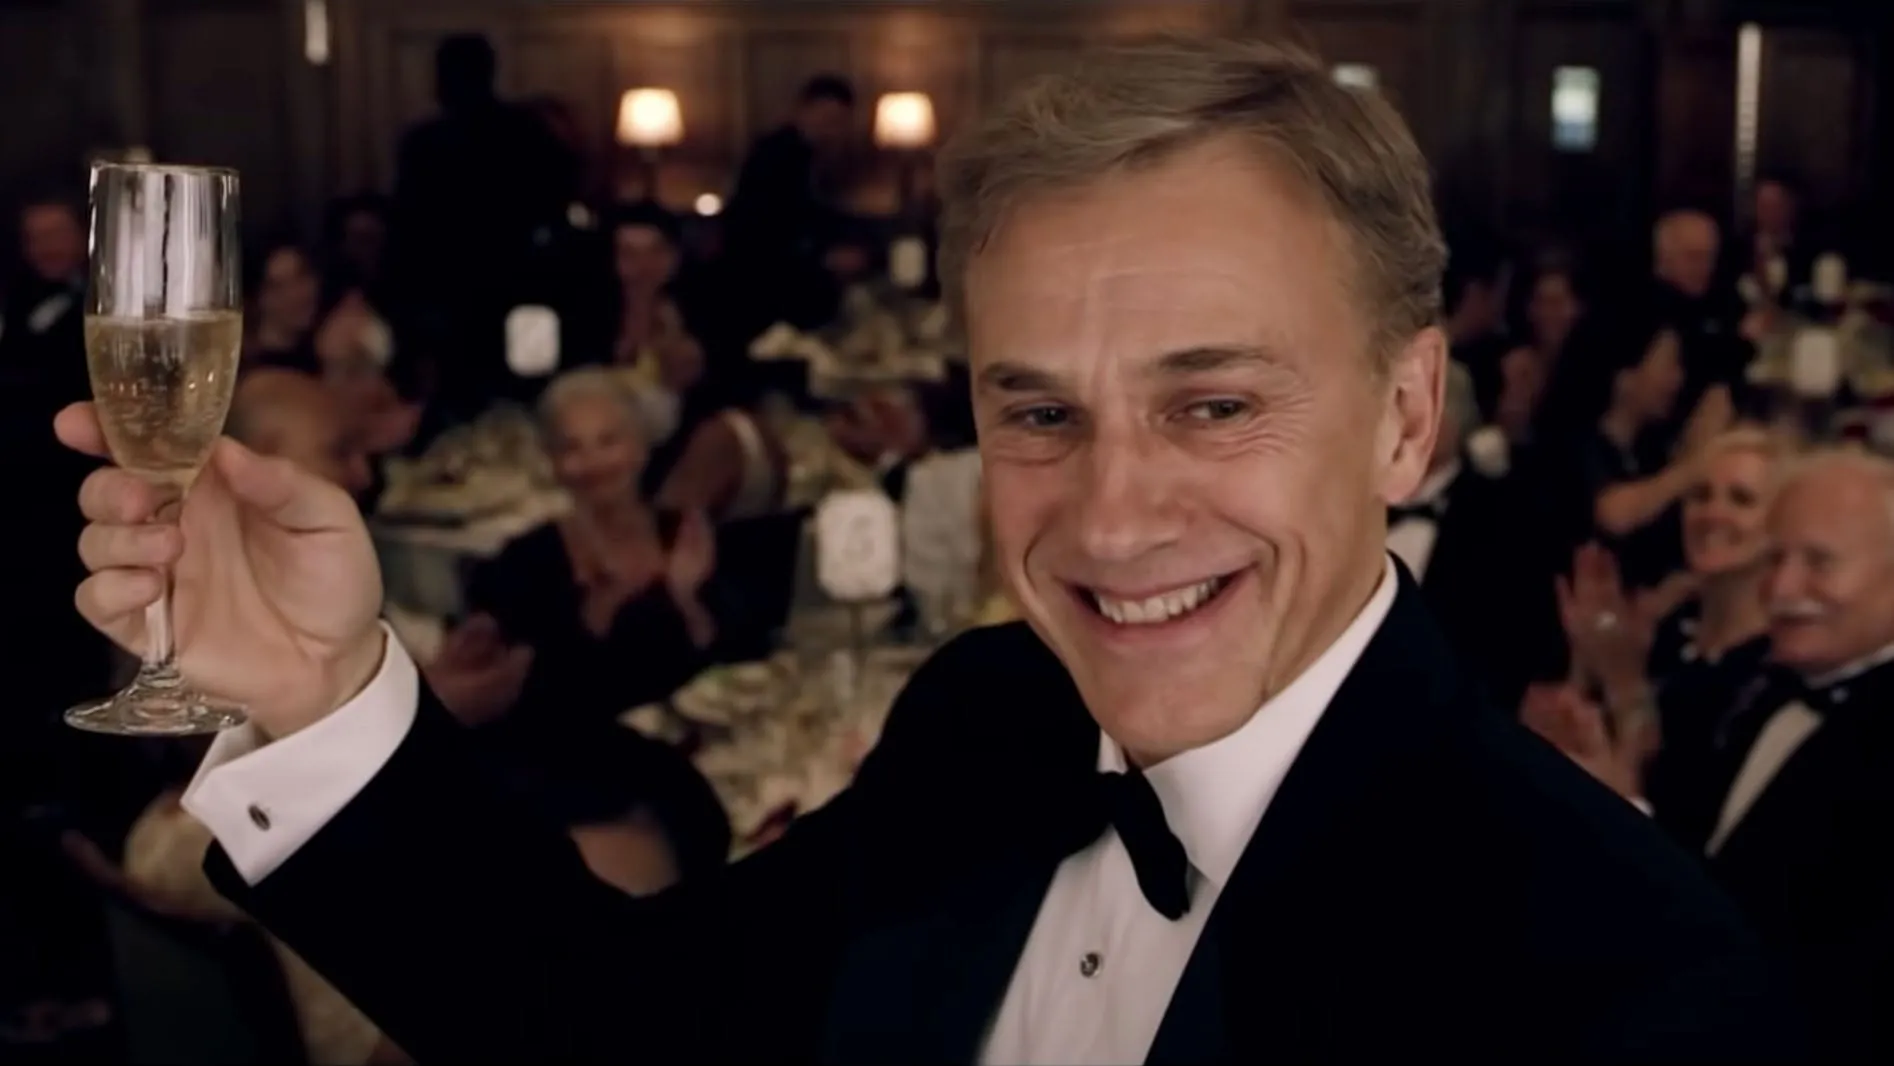Tell me a story about the celebration in this picture Once upon a time in the heart of a bustling city, an esteemed event brought together luminaries from various walks of life. Among them, a distinguished gentleman stood out, wearing a classic black tuxedo. The event was a gala celebrating remarkable achievements in the arts. As the evening progressed, the gentleman, who had just been honored with a prestigious award, raised his glass of champagne to express his gratitude. His radiant smile and the applause from the crowd epitomized the spirit of accomplishment and joy. The evening continued with laughter, heartfelt speeches, and a shared sense of pride among everyone present. Can you describe the color scheme and its effect on the atmosphere? The color scheme of the image predominantly features black, white, and gold, creating an elegant and sophisticated atmosphere. Black and white evoke a sense of timeless class, while gold adds a touch of luxury and festivity. This combination enhances the grandeur of the event, making it feel both formal and celebratory, perfectly fitting for a gala or an awards ceremony. 